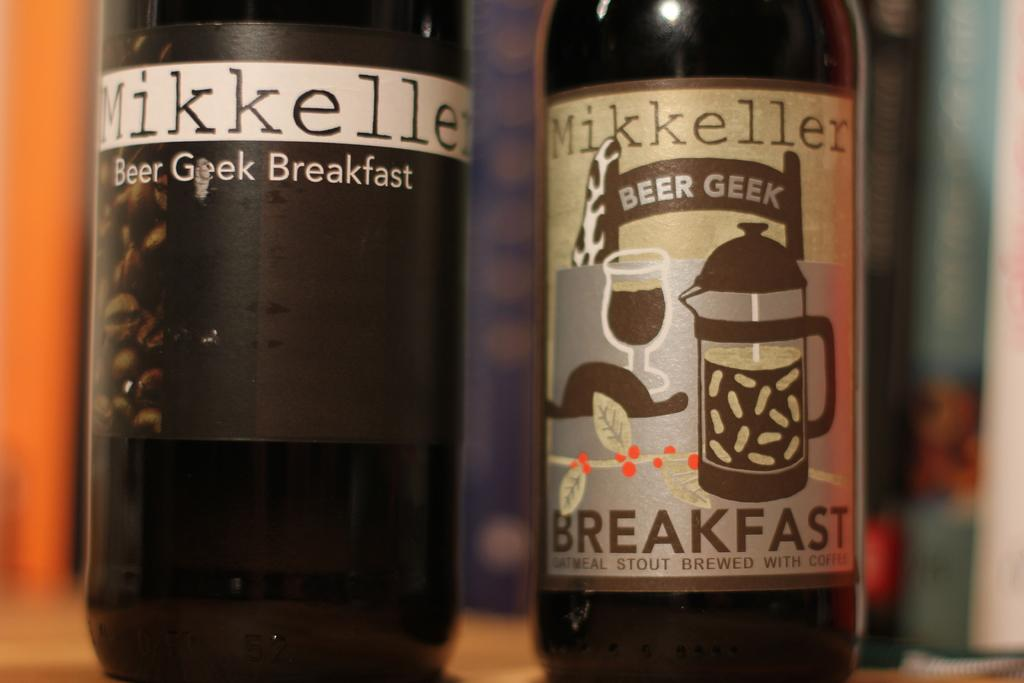Provide a one-sentence caption for the provided image. Two bottles of beer laballed mikkeller, one with breakfast on it. 